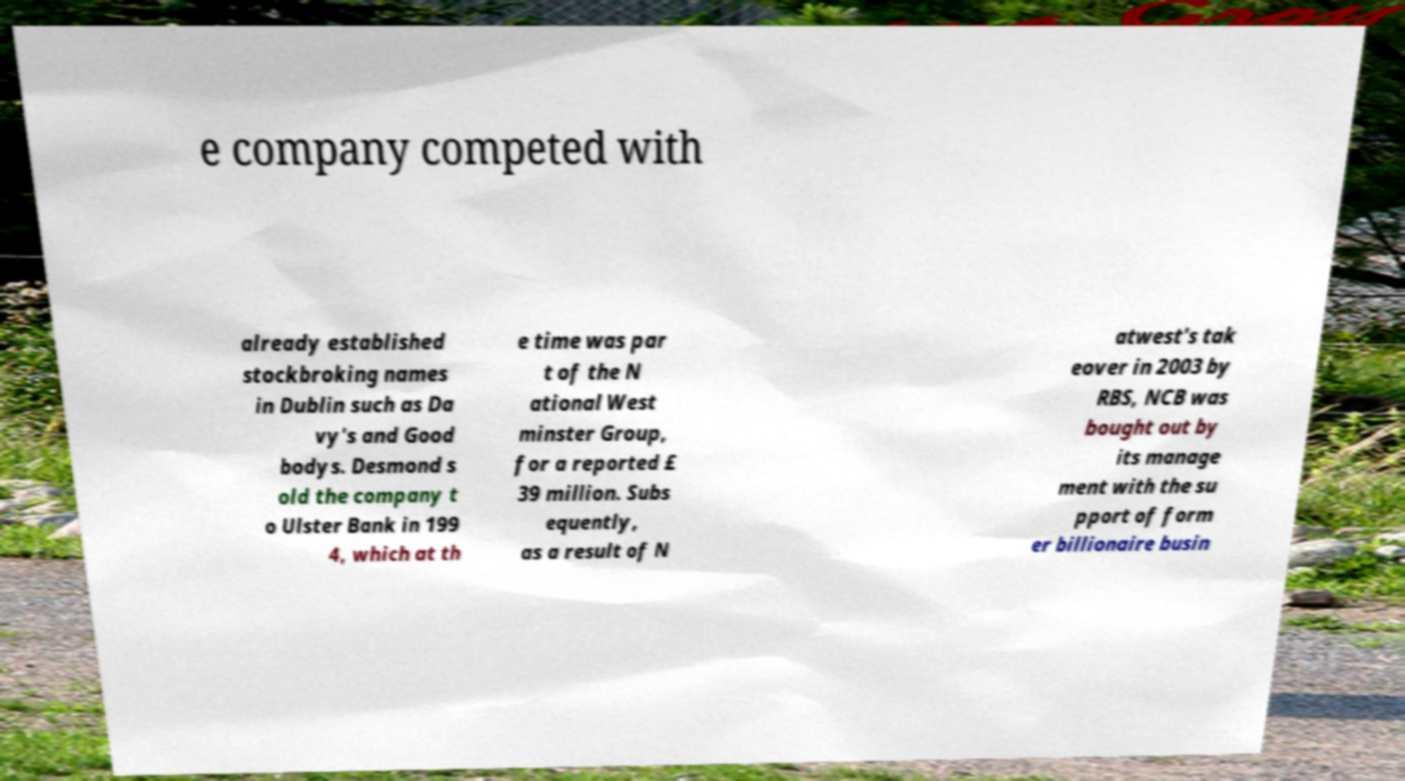For documentation purposes, I need the text within this image transcribed. Could you provide that? e company competed with already established stockbroking names in Dublin such as Da vy's and Good bodys. Desmond s old the company t o Ulster Bank in 199 4, which at th e time was par t of the N ational West minster Group, for a reported £ 39 million. Subs equently, as a result of N atwest's tak eover in 2003 by RBS, NCB was bought out by its manage ment with the su pport of form er billionaire busin 